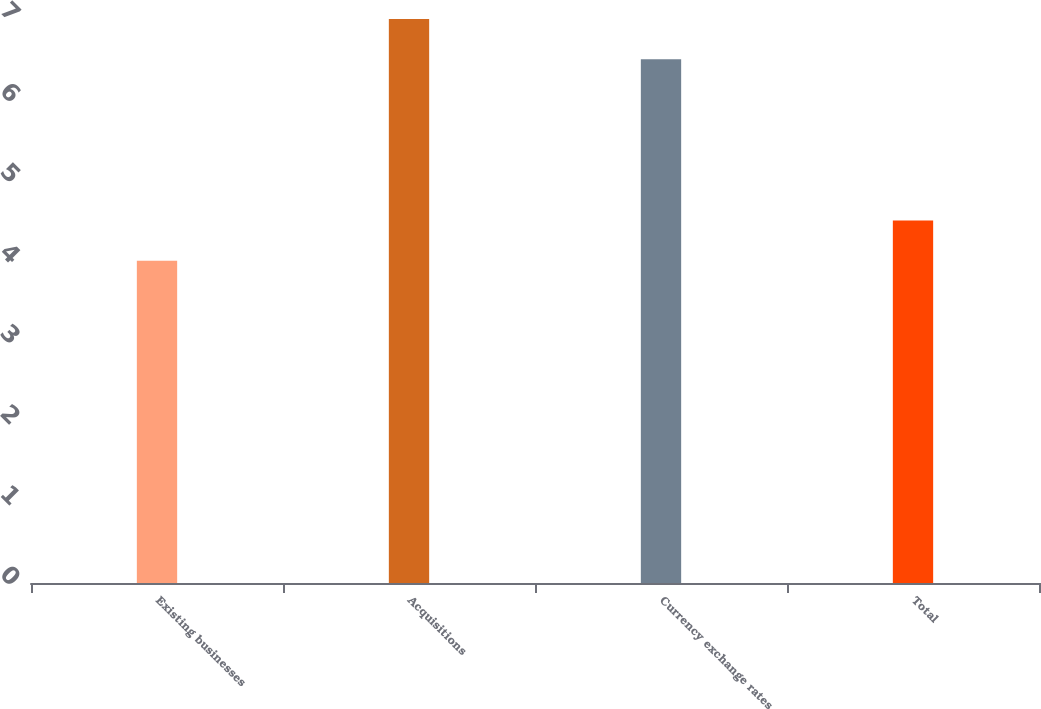Convert chart to OTSL. <chart><loc_0><loc_0><loc_500><loc_500><bar_chart><fcel>Existing businesses<fcel>Acquisitions<fcel>Currency exchange rates<fcel>Total<nl><fcel>4<fcel>7<fcel>6.5<fcel>4.5<nl></chart> 